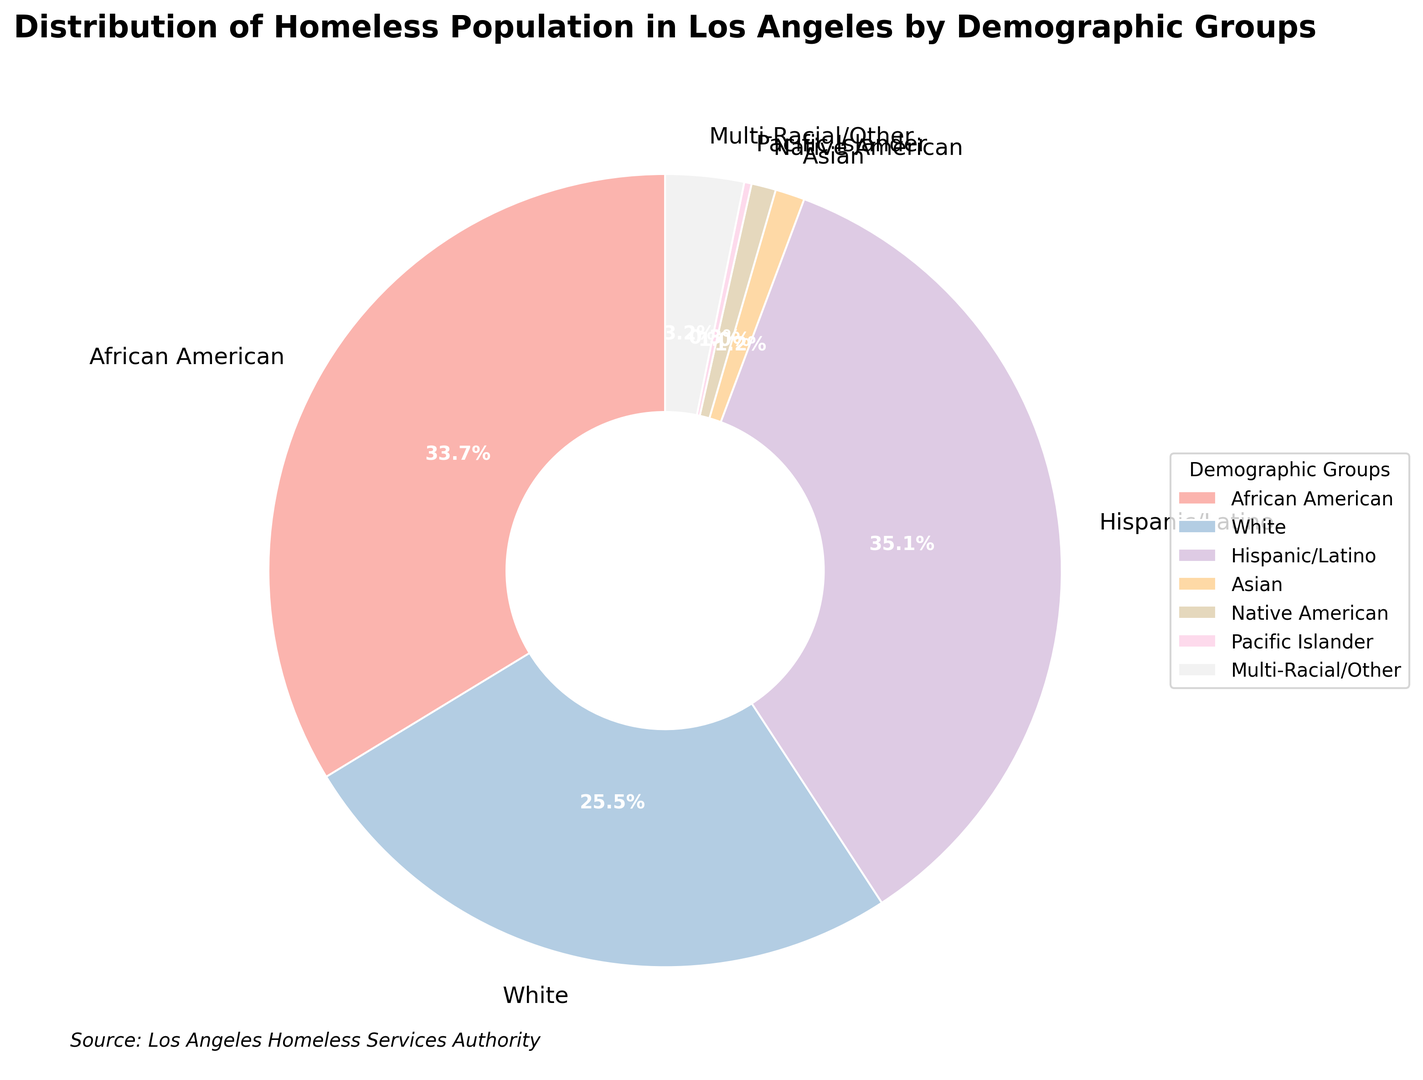Which demographic group has the highest percentage of the homeless population in Los Angeles? The figure shows that the Hispanic/Latino group has the highest percentage at 35.1%.
Answer: Hispanic/Latino What is the combined percentage of the African American and White homeless populations in Los Angeles? The percentages for African American and White groups are 33.7% and 25.5%, respectively. Adding these gives 33.7 + 25.5 = 59.2%.
Answer: 59.2% How does the percentage of the White homeless population compare to that of the African American homeless population? The White population percentage is 25.5%, while the African American percentage is 33.7%. The African American percentage is higher by 33.7 - 25.5 = 8.2%.
Answer: African American percentage is higher by 8.2% Which demographic group has the lowest percentage of the homeless population in Los Angeles? The figure shows that the Pacific Islander group has the lowest percentage at 0.3%.
Answer: Pacific Islander What is the percentage difference between the Hispanic/Latino and Native American homeless populations in Los Angeles? The Hispanic/Latino percentage is 35.1% and the Native American percentage is 1.0%. The difference is 35.1 - 1.0 = 34.1%.
Answer: 34.1% What is the total percentage of homeless populations belonging to groups other than African American, White, and Hispanic/Latino? Sum the percentages of Asian (1.2%), Native American (1.0%), Pacific Islander (0.3%), and Multi-Racial/Other (3.2%). Total is 1.2 + 1.0 + 0.3 + 3.2 = 5.7%.
Answer: 5.7% Which groups have a single-digit percentage of the homeless population in Los Angeles? The groups with single-digit percentages are Asian (1.2%), Native American (1.0%), Pacific Islander (0.3%), and Multi-Racial/Other (3.2%).
Answer: Asian, Native American, Pacific Islander, Multi-Racial/Other What is the difference in homeless population percentages between the African American and Multi-Racial/Other groups? The African American percentage is 33.7%, and the Multi-Racial/Other percentage is 3.2%. The difference is 33.7 - 3.2 = 30.5%.
Answer: 30.5% What is the collective percentage for minority groups (Asian, Native American, Pacific Islander, Multi-Racial/Other) in the homeless population of Los Angeles? The percentages for minority groups are Asian (1.2%), Native American (1.0%), Pacific Islander (0.3%), and Multi-Racial/Other (3.2%). Summing these gives 1.2 + 1.0 + 0.3 + 3.2 = 5.7%.
Answer: 5.7% Is the percentage of the Hispanic/Latino homeless population greater than the combined percentage of the Asian, Native American, and Pacific Islander groups? The Hispanic/Latino percentage is 35.1%. The combined percentage of Asian, Native American, and Pacific Islander groups is 1.2 + 1.0 + 0.3 = 2.5%. The Hispanic/Latino percentage is greater than 2.5%.
Answer: Yes 